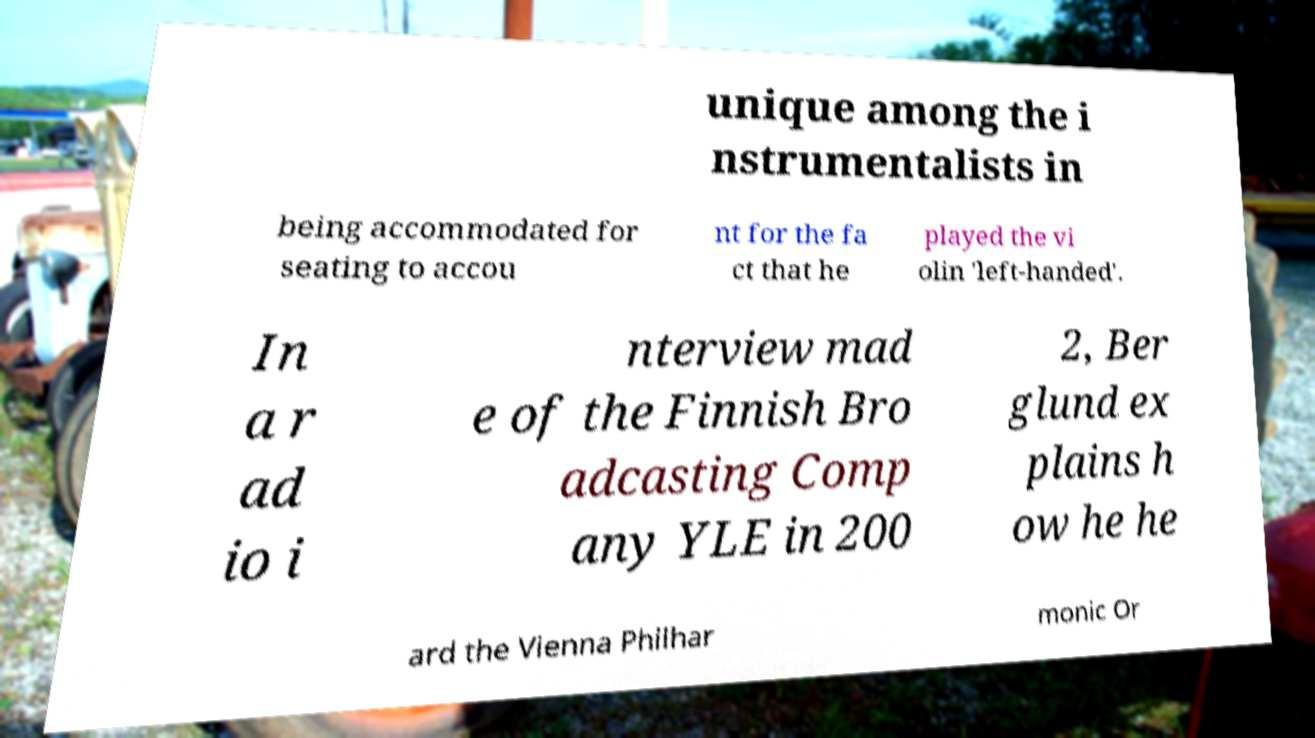Could you assist in decoding the text presented in this image and type it out clearly? unique among the i nstrumentalists in being accommodated for seating to accou nt for the fa ct that he played the vi olin 'left-handed'. In a r ad io i nterview mad e of the Finnish Bro adcasting Comp any YLE in 200 2, Ber glund ex plains h ow he he ard the Vienna Philhar monic Or 